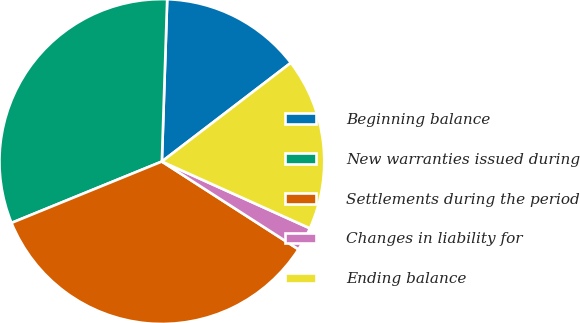<chart> <loc_0><loc_0><loc_500><loc_500><pie_chart><fcel>Beginning balance<fcel>New warranties issued during<fcel>Settlements during the period<fcel>Changes in liability for<fcel>Ending balance<nl><fcel>14.08%<fcel>31.69%<fcel>34.74%<fcel>2.35%<fcel>17.14%<nl></chart> 